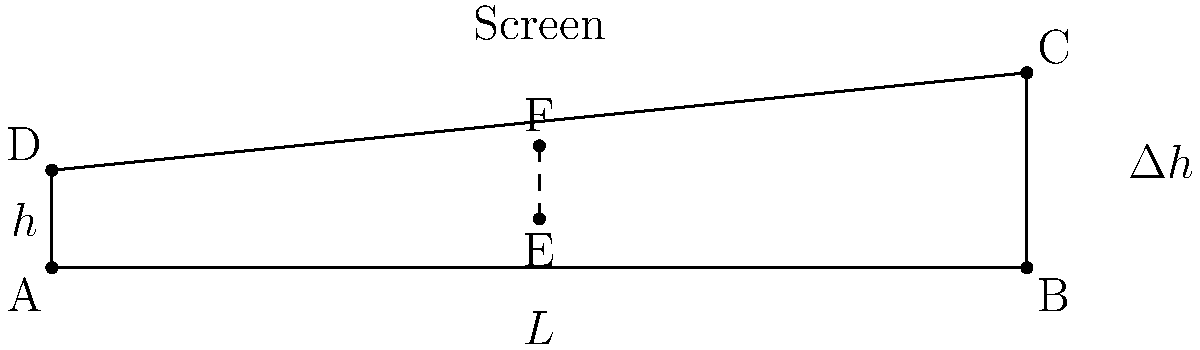In a classic movie theater with a sloped floor, the screen is 10 meters wide and 2 meters high. The first row is 1 meter below the top of the screen, and the last row is level with the bottom of the screen. The theater is 10 meters deep. If a viewer's eyes are 0.5 meters above their seat, what is the minimum height difference $\Delta h$ between each row to ensure an unobstructed view of the entire screen for all viewers? Let's approach this step-by-step:

1) First, we need to find the angle of the sight line from the first row to the top of the screen. This will be our critical angle.

2) The height difference between the viewer's eyes in the first row and the top of the screen is:
   $2 \text{ m} - (1 \text{ m} + 0.5 \text{ m}) = 0.5 \text{ m}$

3) The angle $\theta$ can be calculated using:
   $\tan \theta = \frac{0.5 \text{ m}}{10 \text{ m}} = 0.05$

4) Now, for each subsequent row, we need to maintain this angle. If we divide the theater into $n$ rows, each row will be $\frac{10}{n}$ meters apart.

5) For any two adjacent rows, we have:
   $\tan \theta = \frac{\Delta h}{\frac{10}{n}} = 0.05$

6) Solving for $\Delta h$:
   $\Delta h = 0.05 \cdot \frac{10}{n} = \frac{0.5}{n}$

7) The total height difference across all rows should equal the total height difference from the first to the last row:
   $n \cdot \Delta h = 1 \text{ m}$

8) Substituting our expression for $\Delta h$:
   $n \cdot \frac{0.5}{n} = 1$

9) Simplifying:
   $0.5 = 1$

This equation is always true, confirming that our $\Delta h$ will work for any number of rows.

Therefore, the minimum height difference between each row is $\frac{0.5}{n}$ meters, where $n$ is the number of rows.
Answer: $\frac{0.5}{n}$ meters, where $n$ is the number of rows 